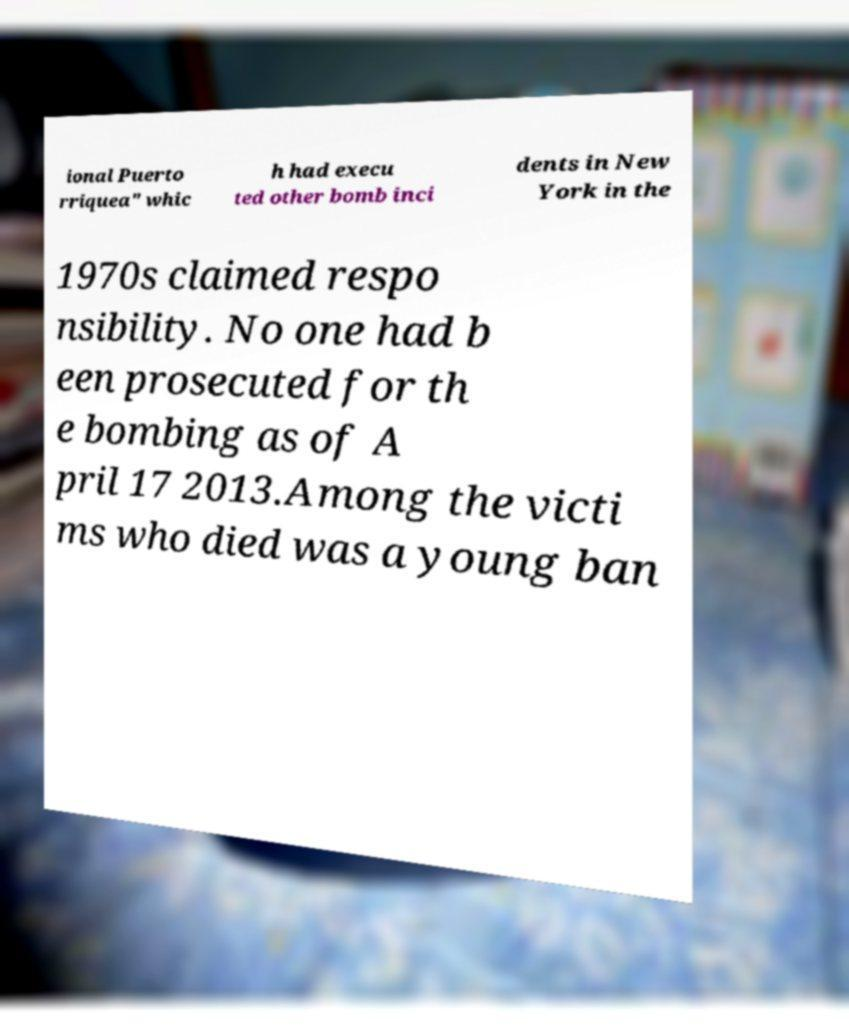I need the written content from this picture converted into text. Can you do that? ional Puerto rriquea" whic h had execu ted other bomb inci dents in New York in the 1970s claimed respo nsibility. No one had b een prosecuted for th e bombing as of A pril 17 2013.Among the victi ms who died was a young ban 